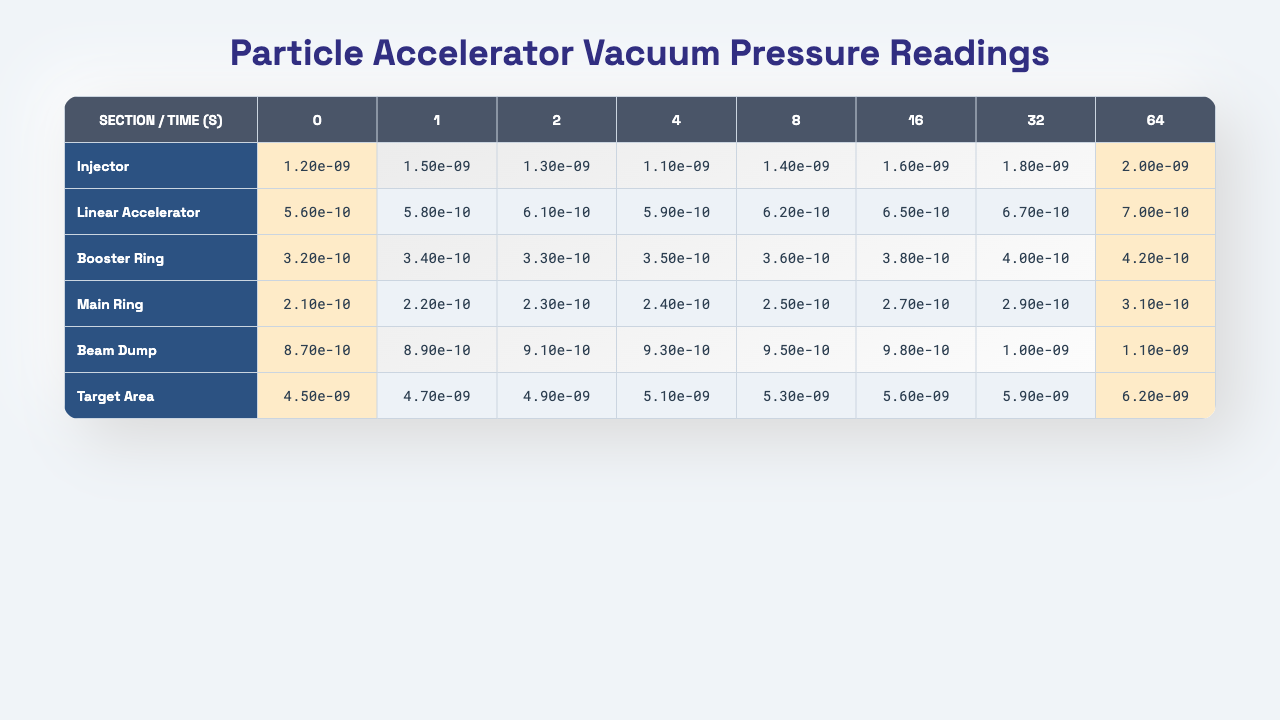What is the vacuum pressure reading at the Injector section at time 0 seconds? According to the table, the vacuum pressure reading for the Injector section at time 0 seconds is 1.2e-9.
Answer: 1.2e-9 What is the highest vacuum pressure reading in the Beam Dump section? By inspecting the Beam Dump section, the highest pressure reading is 1.1e-9, which occurs at time 64 seconds.
Answer: 1.1e-9 What is the vacuum pressure at the Linear Accelerator section at the last time point (64 seconds)? The reading for the Linear Accelerator section at time 64 seconds is 7.0e-10 as shown in the table.
Answer: 7.0e-10 Which section has the lowest vacuum pressure reading at time 8 seconds? Looking at the 8 seconds column, the Booster Ring has the lowest vacuum pressure reading of 3.6e-10.
Answer: Booster Ring What is the average vacuum pressure reading for the Target Area at all time points? Summing all the readings for the Target Area (4.5e-9 + 4.7e-9 + 4.9e-9 + 5.1e-9 + 5.3e-9 + 5.6e-9 + 5.9e-9 + 6.2e-9) results in 43.2e-9. Dividing by 8 time points gives an average of 5.4e-9.
Answer: 5.4e-9 Is the vacuum pressure at time 0 seconds in the Main Ring section greater than that in the Injector section? The vacuum pressure at time 0 seconds in the Main Ring section is 2.1e-10, while in the Injector section it is 1.2e-9. Since 2.1e-10 is less than 1.2e-9, the statement is false.
Answer: No Which section shows the greatest increase in vacuum pressure from the first to the last time point? The increase in vacuum pressure for each section is computed: Injector (2.0e-9 - 1.2e-9 = 0.8e-9), Linear Accelerator (7.0e-10 - 5.6e-10 = 1.4e-10), Booster Ring (4.2e-10 - 3.2e-10 = 1.0e-10), Main Ring (3.1e-10 - 2.1e-10 = 1.0e-10), Beam Dump (1.1e-9 - 8.7e-10 = 2.3e-10), Target Area (6.2e-9 - 4.5e-9 = 1.7e-9). Therefore, the Injector shows the greatest increase of 0.8e-9.
Answer: Injector What is the difference in vacuum pressure readings between the Injector and Target Area at time 16 seconds? At time 16 seconds, the Injector's reading is 1.8e-9 and the Target Area's reading is 5.6e-9. The difference is 5.6e-9 - 1.8e-9 = 3.8e-9.
Answer: 3.8e-9 Did the vacuum pressure reading in the Main Ring increase at every time point? By reviewing the values in the Main Ring section, they are 2.1e-10, 2.2e-10, 2.3e-10, 2.4e-10, 2.5e-10, 2.7e-10, 2.9e-10, 3.1e-10. All readings increase; hence, the answer is yes.
Answer: Yes 